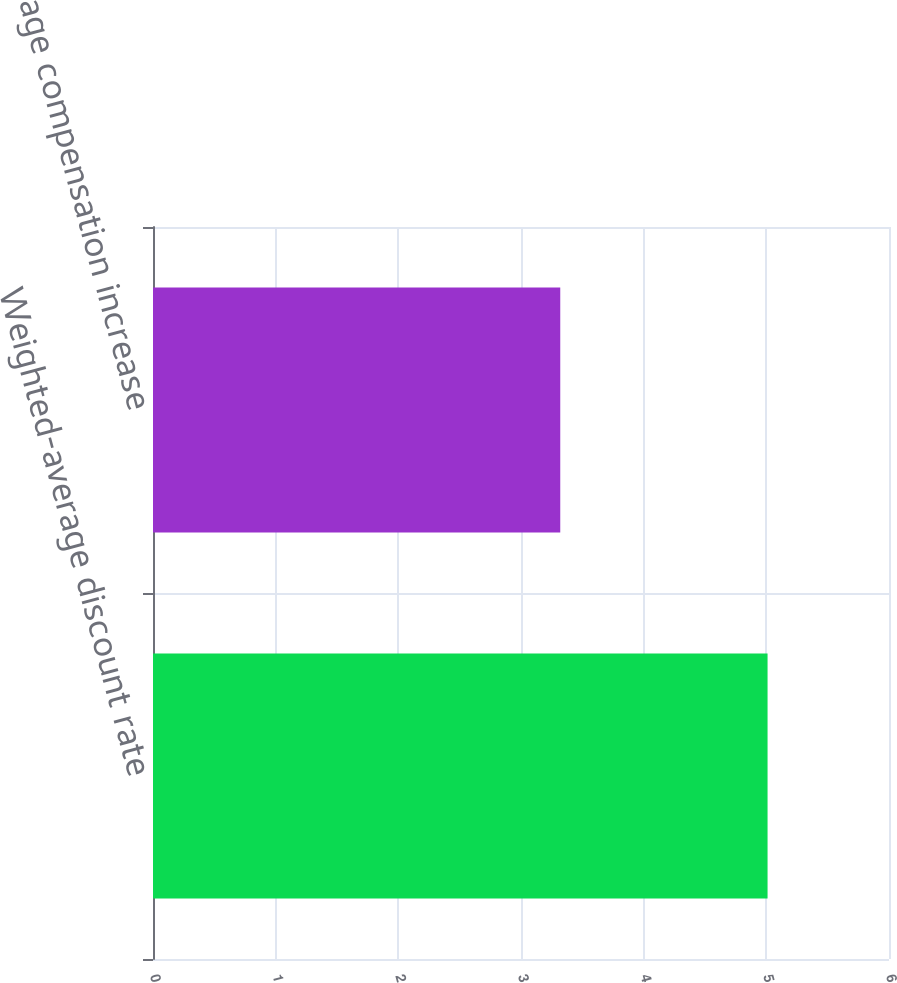Convert chart. <chart><loc_0><loc_0><loc_500><loc_500><bar_chart><fcel>Weighted-average discount rate<fcel>Average compensation increase<nl><fcel>5.01<fcel>3.32<nl></chart> 